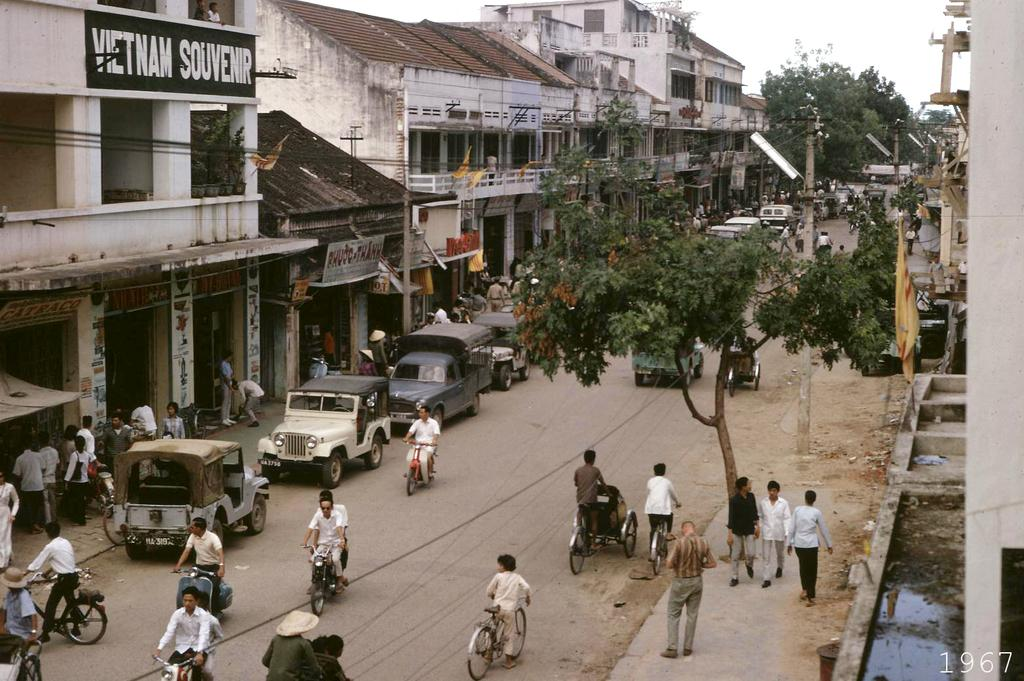Provide a one-sentence caption for the provided image. A village of people that are walking an riding scooters down a street of buildings on both sides and one building called Vietnam Souvenir. 